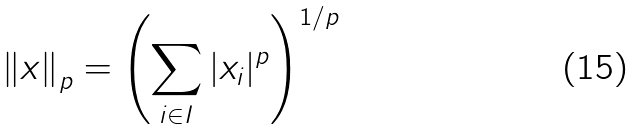<formula> <loc_0><loc_0><loc_500><loc_500>\left \| x \right \| _ { p } = \left ( \sum _ { i \in I } | x _ { i } | ^ { p } \right ) ^ { 1 / p }</formula> 